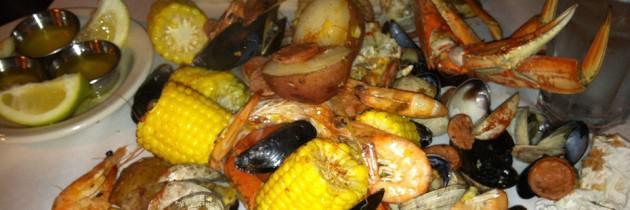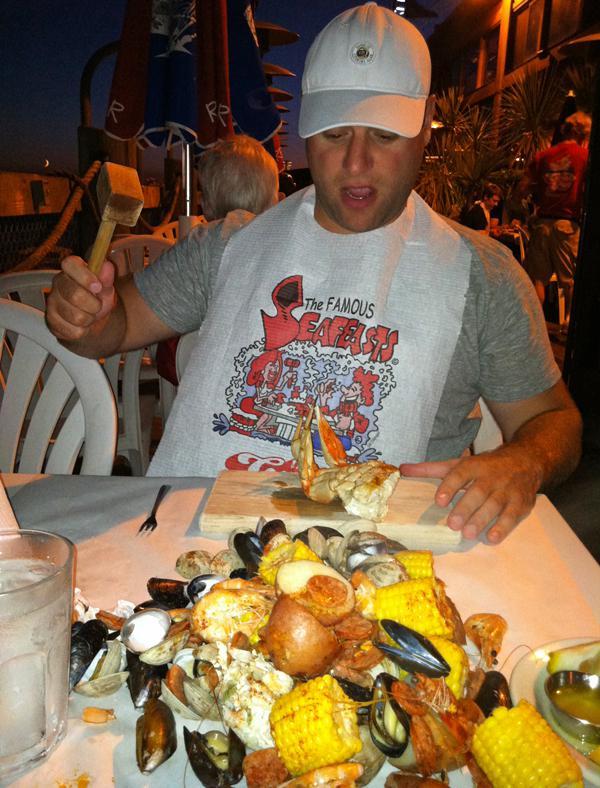The first image is the image on the left, the second image is the image on the right. Given the left and right images, does the statement "An image shows a man standing in front of a display of fish with his arms raised to catch a fish coming toward him." hold true? Answer yes or no. No. The first image is the image on the left, the second image is the image on the right. For the images displayed, is the sentence "In one image, a man near a display of iced fish has his arms outstretched, while a second image shows iced crabs and crab legs for sale." factually correct? Answer yes or no. No. 